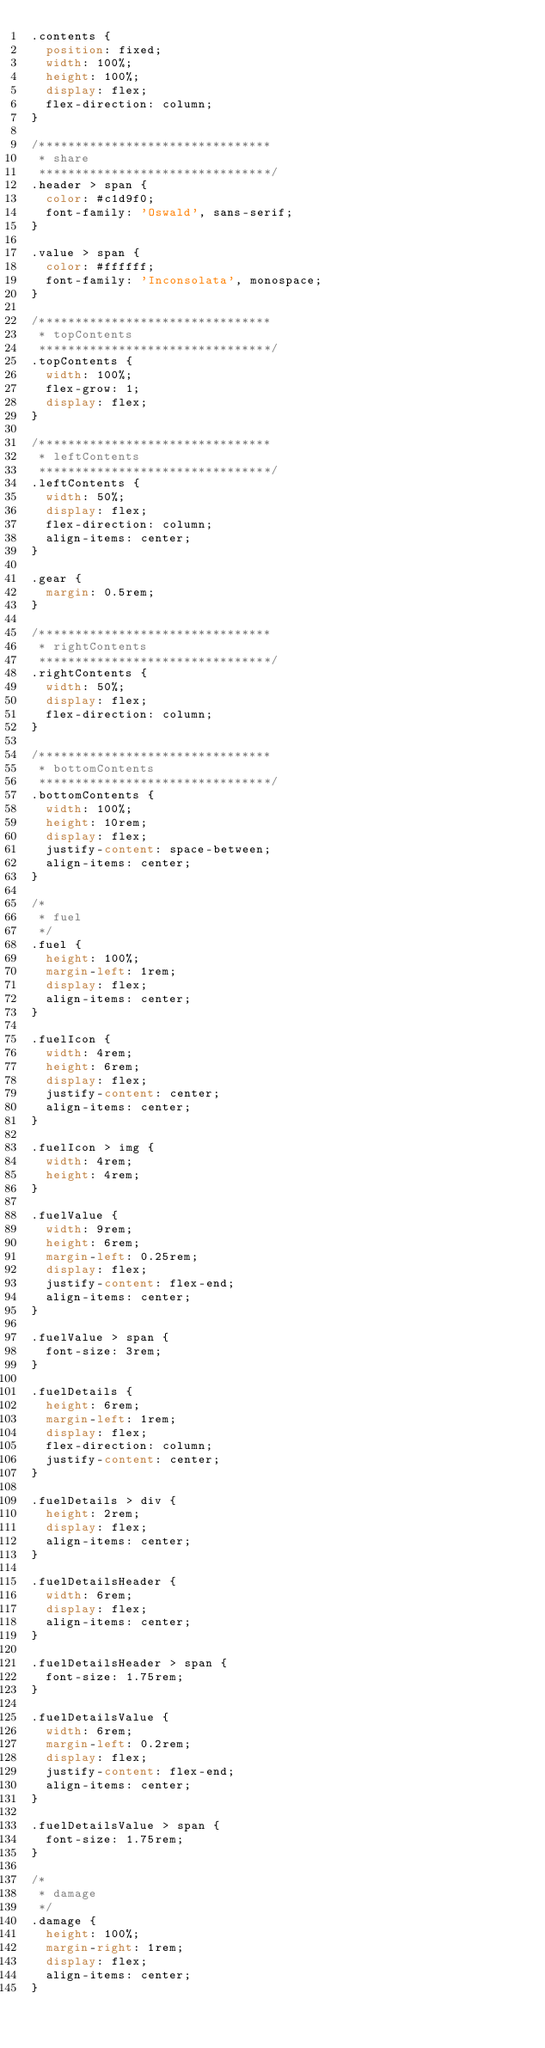Convert code to text. <code><loc_0><loc_0><loc_500><loc_500><_CSS_>.contents {
  position: fixed;
  width: 100%;
  height: 100%;
  display: flex;
  flex-direction: column;
}

/********************************
 * share
 ********************************/
.header > span {
  color: #c1d9f0;
  font-family: 'Oswald', sans-serif;
}

.value > span {
  color: #ffffff;
  font-family: 'Inconsolata', monospace;
}

/********************************
 * topContents
 ********************************/
.topContents {
  width: 100%;
  flex-grow: 1;
  display: flex;
}

/********************************
 * leftContents
 ********************************/
.leftContents {
  width: 50%;
  display: flex;
  flex-direction: column;
  align-items: center;
}

.gear {
  margin: 0.5rem;
}

/********************************
 * rightContents
 ********************************/
.rightContents {
  width: 50%;
  display: flex;
  flex-direction: column;
}

/********************************
 * bottomContents
 ********************************/
.bottomContents {
  width: 100%;
  height: 10rem;
  display: flex;
  justify-content: space-between;
  align-items: center;
}

/*
 * fuel
 */
.fuel {
  height: 100%;
  margin-left: 1rem;
  display: flex;
  align-items: center;
}

.fuelIcon {
  width: 4rem;
  height: 6rem;
  display: flex;
  justify-content: center;
  align-items: center;
}

.fuelIcon > img {
  width: 4rem;
  height: 4rem;
}

.fuelValue {
  width: 9rem;
  height: 6rem;
  margin-left: 0.25rem;
  display: flex;
  justify-content: flex-end;
  align-items: center;
}

.fuelValue > span {
  font-size: 3rem;
}

.fuelDetails {
  height: 6rem;
  margin-left: 1rem;
  display: flex;
  flex-direction: column;
  justify-content: center;
}

.fuelDetails > div {
  height: 2rem;
  display: flex;
  align-items: center;
}

.fuelDetailsHeader {
  width: 6rem;
  display: flex;
  align-items: center;
}

.fuelDetailsHeader > span {
  font-size: 1.75rem;
}

.fuelDetailsValue {
  width: 6rem;
  margin-left: 0.2rem;
  display: flex;
  justify-content: flex-end;
  align-items: center;
}

.fuelDetailsValue > span {
  font-size: 1.75rem;
}

/*
 * damage
 */
.damage {
  height: 100%;
  margin-right: 1rem;
  display: flex;
  align-items: center;
}
</code> 